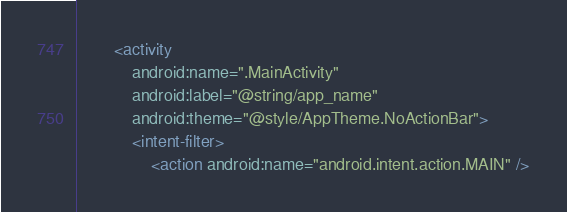Convert code to text. <code><loc_0><loc_0><loc_500><loc_500><_XML_>        <activity
            android:name=".MainActivity"
            android:label="@string/app_name"
            android:theme="@style/AppTheme.NoActionBar">
            <intent-filter>
                <action android:name="android.intent.action.MAIN" />
</code> 